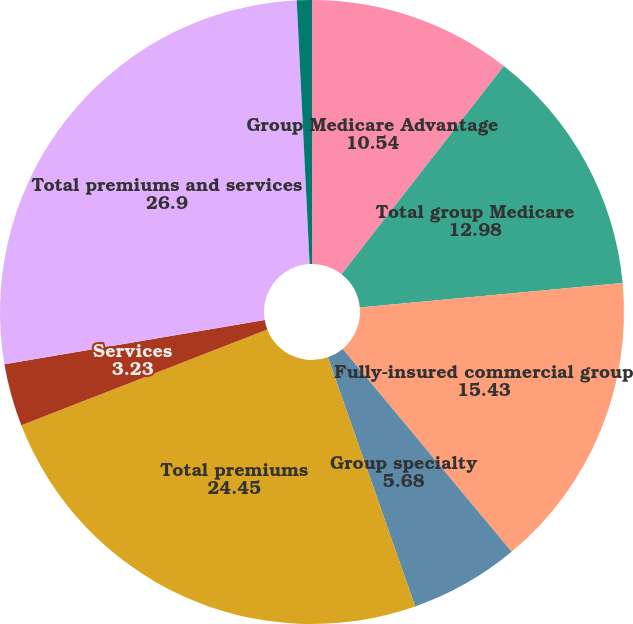<chart> <loc_0><loc_0><loc_500><loc_500><pie_chart><fcel>Group Medicare Advantage<fcel>Total group Medicare<fcel>Fully-insured commercial group<fcel>Group specialty<fcel>Total premiums<fcel>Services<fcel>Total premiums and services<fcel>Income before income taxes<nl><fcel>10.54%<fcel>12.98%<fcel>15.43%<fcel>5.68%<fcel>24.45%<fcel>3.23%<fcel>26.9%<fcel>0.78%<nl></chart> 